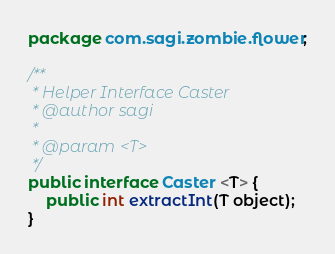<code> <loc_0><loc_0><loc_500><loc_500><_Java_>package com.sagi.zombie.flower;

/**
 * Helper Interface Caster
 * @author sagi
 *
 * @param <T>
 */
public interface Caster <T> {
	public int extractInt(T object);
}
</code> 